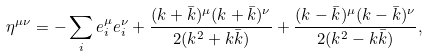Convert formula to latex. <formula><loc_0><loc_0><loc_500><loc_500>\eta ^ { \mu \nu } = - \sum _ { i } e ^ { \mu } _ { i } e ^ { \nu } _ { i } + \frac { ( k + \bar { k } ) ^ { \mu } ( k + \bar { k } ) ^ { \nu } } { 2 ( k ^ { 2 } + k \bar { k } ) } + \frac { ( k - \bar { k } ) ^ { \mu } ( k - \bar { k } ) ^ { \nu } } { 2 ( k ^ { 2 } - k \bar { k } ) } ,</formula> 